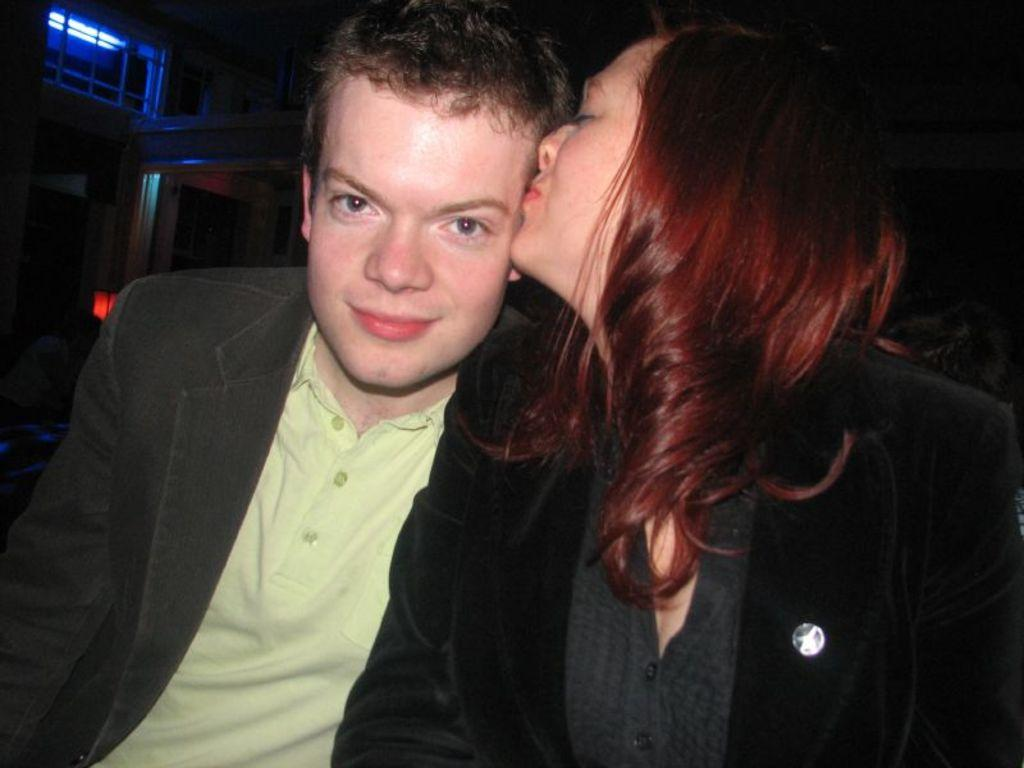How many people are in the image? There are two people in the image, a woman and a man. What are the two people doing in the image? The woman is kissing the man. What can be seen behind the people in the image? There are objects visible behind the people. What type of debt is being discussed by the woman and man in the image? There is no indication in the image that the woman and man are discussing debt, as they are engaged in a romantic interaction. 